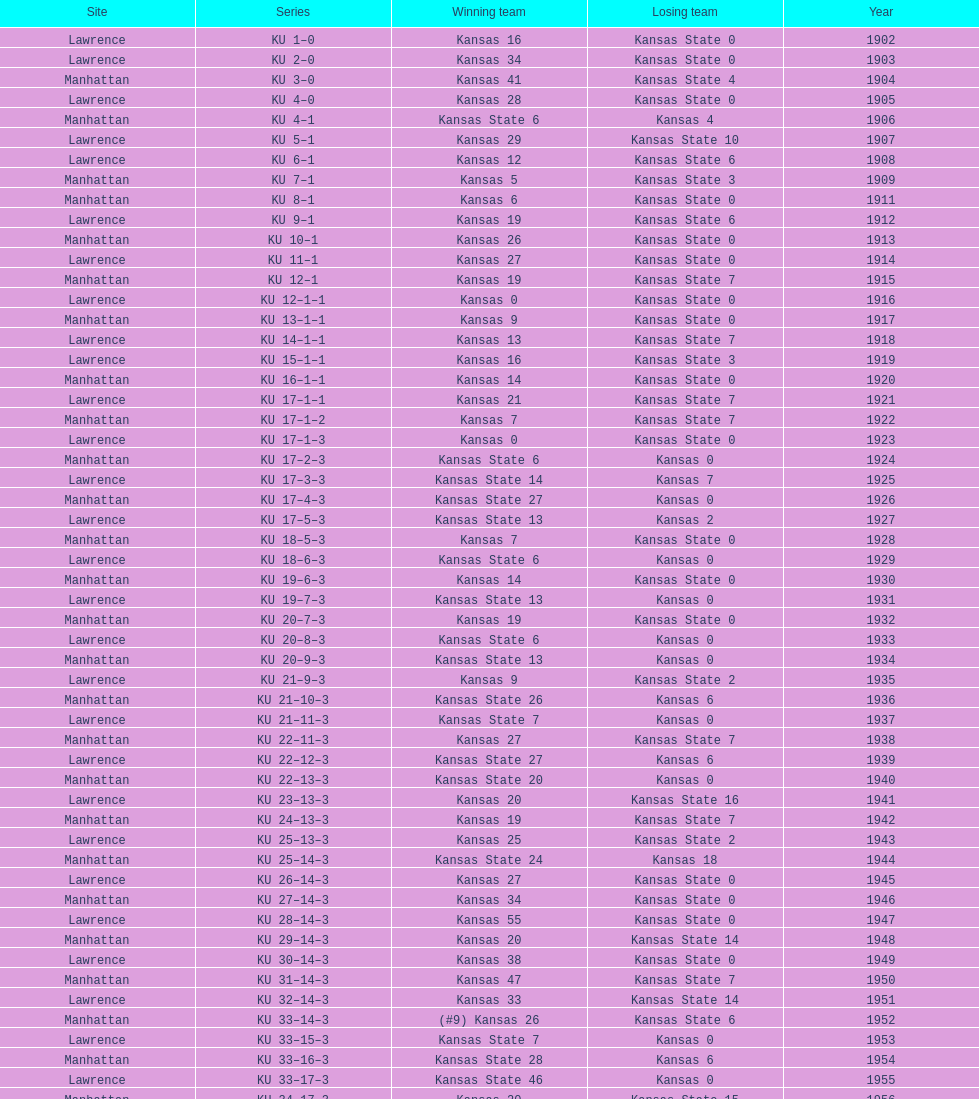How many times did kansas state not score at all against kansas from 1902-1968? 23. 